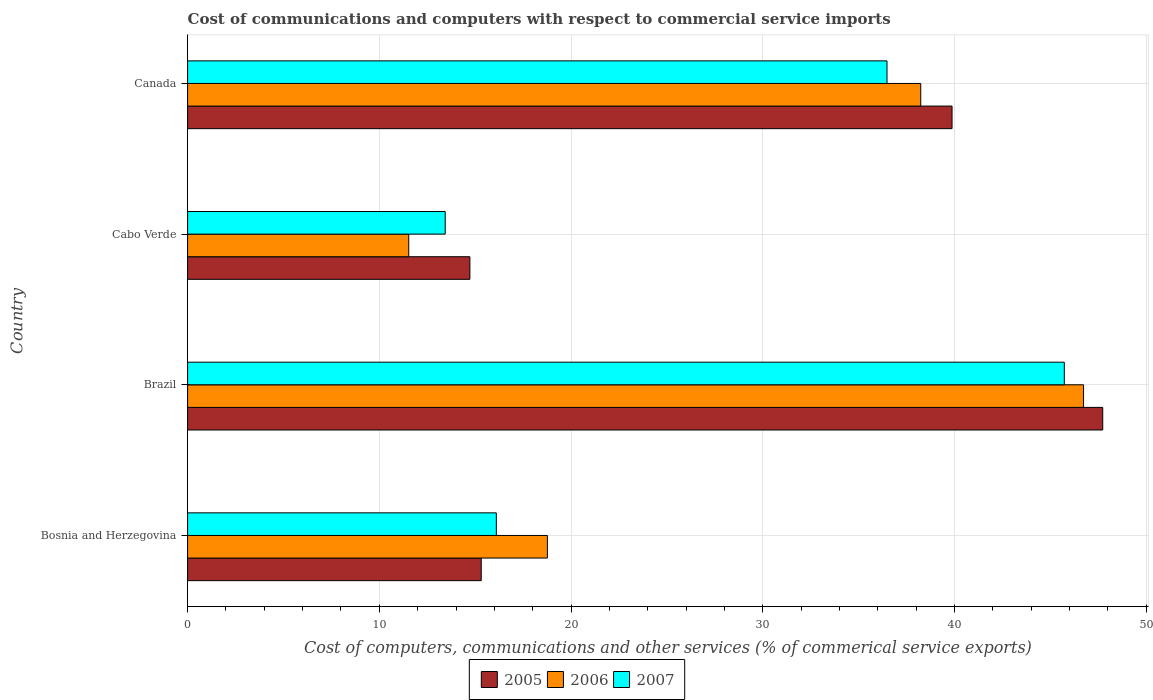How many groups of bars are there?
Your answer should be very brief. 4. Are the number of bars on each tick of the Y-axis equal?
Keep it short and to the point. Yes. How many bars are there on the 4th tick from the top?
Give a very brief answer. 3. What is the label of the 4th group of bars from the top?
Make the answer very short. Bosnia and Herzegovina. In how many cases, is the number of bars for a given country not equal to the number of legend labels?
Your response must be concise. 0. What is the cost of communications and computers in 2005 in Brazil?
Ensure brevity in your answer.  47.73. Across all countries, what is the maximum cost of communications and computers in 2006?
Offer a very short reply. 46.73. Across all countries, what is the minimum cost of communications and computers in 2007?
Your answer should be compact. 13.44. In which country was the cost of communications and computers in 2005 minimum?
Make the answer very short. Cabo Verde. What is the total cost of communications and computers in 2005 in the graph?
Provide a succinct answer. 117.63. What is the difference between the cost of communications and computers in 2007 in Cabo Verde and that in Canada?
Your response must be concise. -23.04. What is the difference between the cost of communications and computers in 2005 in Cabo Verde and the cost of communications and computers in 2007 in Brazil?
Offer a terse response. -31. What is the average cost of communications and computers in 2005 per country?
Give a very brief answer. 29.41. What is the difference between the cost of communications and computers in 2007 and cost of communications and computers in 2006 in Brazil?
Your answer should be compact. -1. What is the ratio of the cost of communications and computers in 2007 in Bosnia and Herzegovina to that in Cabo Verde?
Ensure brevity in your answer.  1.2. Is the cost of communications and computers in 2006 in Brazil less than that in Canada?
Your response must be concise. No. What is the difference between the highest and the second highest cost of communications and computers in 2007?
Provide a short and direct response. 9.25. What is the difference between the highest and the lowest cost of communications and computers in 2006?
Provide a short and direct response. 35.19. In how many countries, is the cost of communications and computers in 2007 greater than the average cost of communications and computers in 2007 taken over all countries?
Offer a terse response. 2. Is it the case that in every country, the sum of the cost of communications and computers in 2005 and cost of communications and computers in 2007 is greater than the cost of communications and computers in 2006?
Provide a short and direct response. Yes. How many countries are there in the graph?
Your answer should be very brief. 4. Does the graph contain grids?
Your answer should be compact. Yes. Where does the legend appear in the graph?
Offer a terse response. Bottom center. What is the title of the graph?
Offer a very short reply. Cost of communications and computers with respect to commercial service imports. Does "1997" appear as one of the legend labels in the graph?
Your response must be concise. No. What is the label or title of the X-axis?
Keep it short and to the point. Cost of computers, communications and other services (% of commerical service exports). What is the label or title of the Y-axis?
Provide a succinct answer. Country. What is the Cost of computers, communications and other services (% of commerical service exports) of 2005 in Bosnia and Herzegovina?
Provide a short and direct response. 15.31. What is the Cost of computers, communications and other services (% of commerical service exports) in 2006 in Bosnia and Herzegovina?
Provide a short and direct response. 18.76. What is the Cost of computers, communications and other services (% of commerical service exports) of 2007 in Bosnia and Herzegovina?
Your answer should be very brief. 16.1. What is the Cost of computers, communications and other services (% of commerical service exports) in 2005 in Brazil?
Provide a succinct answer. 47.73. What is the Cost of computers, communications and other services (% of commerical service exports) of 2006 in Brazil?
Offer a very short reply. 46.73. What is the Cost of computers, communications and other services (% of commerical service exports) of 2007 in Brazil?
Make the answer very short. 45.72. What is the Cost of computers, communications and other services (% of commerical service exports) in 2005 in Cabo Verde?
Offer a very short reply. 14.72. What is the Cost of computers, communications and other services (% of commerical service exports) in 2006 in Cabo Verde?
Your answer should be very brief. 11.53. What is the Cost of computers, communications and other services (% of commerical service exports) of 2007 in Cabo Verde?
Your response must be concise. 13.44. What is the Cost of computers, communications and other services (% of commerical service exports) of 2005 in Canada?
Your answer should be very brief. 39.87. What is the Cost of computers, communications and other services (% of commerical service exports) of 2006 in Canada?
Provide a succinct answer. 38.24. What is the Cost of computers, communications and other services (% of commerical service exports) in 2007 in Canada?
Your response must be concise. 36.48. Across all countries, what is the maximum Cost of computers, communications and other services (% of commerical service exports) in 2005?
Offer a very short reply. 47.73. Across all countries, what is the maximum Cost of computers, communications and other services (% of commerical service exports) in 2006?
Your answer should be very brief. 46.73. Across all countries, what is the maximum Cost of computers, communications and other services (% of commerical service exports) in 2007?
Give a very brief answer. 45.72. Across all countries, what is the minimum Cost of computers, communications and other services (% of commerical service exports) in 2005?
Your answer should be compact. 14.72. Across all countries, what is the minimum Cost of computers, communications and other services (% of commerical service exports) in 2006?
Offer a very short reply. 11.53. Across all countries, what is the minimum Cost of computers, communications and other services (% of commerical service exports) of 2007?
Offer a terse response. 13.44. What is the total Cost of computers, communications and other services (% of commerical service exports) of 2005 in the graph?
Your answer should be compact. 117.63. What is the total Cost of computers, communications and other services (% of commerical service exports) of 2006 in the graph?
Your response must be concise. 115.26. What is the total Cost of computers, communications and other services (% of commerical service exports) in 2007 in the graph?
Ensure brevity in your answer.  111.74. What is the difference between the Cost of computers, communications and other services (% of commerical service exports) in 2005 in Bosnia and Herzegovina and that in Brazil?
Provide a short and direct response. -32.41. What is the difference between the Cost of computers, communications and other services (% of commerical service exports) in 2006 in Bosnia and Herzegovina and that in Brazil?
Make the answer very short. -27.96. What is the difference between the Cost of computers, communications and other services (% of commerical service exports) of 2007 in Bosnia and Herzegovina and that in Brazil?
Keep it short and to the point. -29.62. What is the difference between the Cost of computers, communications and other services (% of commerical service exports) of 2005 in Bosnia and Herzegovina and that in Cabo Verde?
Offer a terse response. 0.59. What is the difference between the Cost of computers, communications and other services (% of commerical service exports) of 2006 in Bosnia and Herzegovina and that in Cabo Verde?
Provide a succinct answer. 7.23. What is the difference between the Cost of computers, communications and other services (% of commerical service exports) in 2007 in Bosnia and Herzegovina and that in Cabo Verde?
Keep it short and to the point. 2.67. What is the difference between the Cost of computers, communications and other services (% of commerical service exports) of 2005 in Bosnia and Herzegovina and that in Canada?
Make the answer very short. -24.55. What is the difference between the Cost of computers, communications and other services (% of commerical service exports) in 2006 in Bosnia and Herzegovina and that in Canada?
Your response must be concise. -19.47. What is the difference between the Cost of computers, communications and other services (% of commerical service exports) in 2007 in Bosnia and Herzegovina and that in Canada?
Your answer should be compact. -20.38. What is the difference between the Cost of computers, communications and other services (% of commerical service exports) in 2005 in Brazil and that in Cabo Verde?
Your answer should be compact. 33.01. What is the difference between the Cost of computers, communications and other services (% of commerical service exports) in 2006 in Brazil and that in Cabo Verde?
Your response must be concise. 35.19. What is the difference between the Cost of computers, communications and other services (% of commerical service exports) in 2007 in Brazil and that in Cabo Verde?
Your answer should be compact. 32.29. What is the difference between the Cost of computers, communications and other services (% of commerical service exports) in 2005 in Brazil and that in Canada?
Ensure brevity in your answer.  7.86. What is the difference between the Cost of computers, communications and other services (% of commerical service exports) of 2006 in Brazil and that in Canada?
Make the answer very short. 8.49. What is the difference between the Cost of computers, communications and other services (% of commerical service exports) in 2007 in Brazil and that in Canada?
Ensure brevity in your answer.  9.25. What is the difference between the Cost of computers, communications and other services (% of commerical service exports) of 2005 in Cabo Verde and that in Canada?
Ensure brevity in your answer.  -25.15. What is the difference between the Cost of computers, communications and other services (% of commerical service exports) of 2006 in Cabo Verde and that in Canada?
Ensure brevity in your answer.  -26.7. What is the difference between the Cost of computers, communications and other services (% of commerical service exports) of 2007 in Cabo Verde and that in Canada?
Offer a terse response. -23.04. What is the difference between the Cost of computers, communications and other services (% of commerical service exports) in 2005 in Bosnia and Herzegovina and the Cost of computers, communications and other services (% of commerical service exports) in 2006 in Brazil?
Offer a terse response. -31.41. What is the difference between the Cost of computers, communications and other services (% of commerical service exports) in 2005 in Bosnia and Herzegovina and the Cost of computers, communications and other services (% of commerical service exports) in 2007 in Brazil?
Your answer should be very brief. -30.41. What is the difference between the Cost of computers, communications and other services (% of commerical service exports) in 2006 in Bosnia and Herzegovina and the Cost of computers, communications and other services (% of commerical service exports) in 2007 in Brazil?
Give a very brief answer. -26.96. What is the difference between the Cost of computers, communications and other services (% of commerical service exports) of 2005 in Bosnia and Herzegovina and the Cost of computers, communications and other services (% of commerical service exports) of 2006 in Cabo Verde?
Your answer should be compact. 3.78. What is the difference between the Cost of computers, communications and other services (% of commerical service exports) in 2005 in Bosnia and Herzegovina and the Cost of computers, communications and other services (% of commerical service exports) in 2007 in Cabo Verde?
Your answer should be compact. 1.88. What is the difference between the Cost of computers, communications and other services (% of commerical service exports) of 2006 in Bosnia and Herzegovina and the Cost of computers, communications and other services (% of commerical service exports) of 2007 in Cabo Verde?
Make the answer very short. 5.33. What is the difference between the Cost of computers, communications and other services (% of commerical service exports) of 2005 in Bosnia and Herzegovina and the Cost of computers, communications and other services (% of commerical service exports) of 2006 in Canada?
Give a very brief answer. -22.92. What is the difference between the Cost of computers, communications and other services (% of commerical service exports) of 2005 in Bosnia and Herzegovina and the Cost of computers, communications and other services (% of commerical service exports) of 2007 in Canada?
Your answer should be compact. -21.16. What is the difference between the Cost of computers, communications and other services (% of commerical service exports) in 2006 in Bosnia and Herzegovina and the Cost of computers, communications and other services (% of commerical service exports) in 2007 in Canada?
Make the answer very short. -17.71. What is the difference between the Cost of computers, communications and other services (% of commerical service exports) of 2005 in Brazil and the Cost of computers, communications and other services (% of commerical service exports) of 2006 in Cabo Verde?
Your answer should be very brief. 36.2. What is the difference between the Cost of computers, communications and other services (% of commerical service exports) in 2005 in Brazil and the Cost of computers, communications and other services (% of commerical service exports) in 2007 in Cabo Verde?
Keep it short and to the point. 34.29. What is the difference between the Cost of computers, communications and other services (% of commerical service exports) in 2006 in Brazil and the Cost of computers, communications and other services (% of commerical service exports) in 2007 in Cabo Verde?
Keep it short and to the point. 33.29. What is the difference between the Cost of computers, communications and other services (% of commerical service exports) in 2005 in Brazil and the Cost of computers, communications and other services (% of commerical service exports) in 2006 in Canada?
Give a very brief answer. 9.49. What is the difference between the Cost of computers, communications and other services (% of commerical service exports) in 2005 in Brazil and the Cost of computers, communications and other services (% of commerical service exports) in 2007 in Canada?
Ensure brevity in your answer.  11.25. What is the difference between the Cost of computers, communications and other services (% of commerical service exports) of 2006 in Brazil and the Cost of computers, communications and other services (% of commerical service exports) of 2007 in Canada?
Offer a terse response. 10.25. What is the difference between the Cost of computers, communications and other services (% of commerical service exports) of 2005 in Cabo Verde and the Cost of computers, communications and other services (% of commerical service exports) of 2006 in Canada?
Offer a very short reply. -23.51. What is the difference between the Cost of computers, communications and other services (% of commerical service exports) in 2005 in Cabo Verde and the Cost of computers, communications and other services (% of commerical service exports) in 2007 in Canada?
Keep it short and to the point. -21.75. What is the difference between the Cost of computers, communications and other services (% of commerical service exports) in 2006 in Cabo Verde and the Cost of computers, communications and other services (% of commerical service exports) in 2007 in Canada?
Offer a very short reply. -24.94. What is the average Cost of computers, communications and other services (% of commerical service exports) in 2005 per country?
Ensure brevity in your answer.  29.41. What is the average Cost of computers, communications and other services (% of commerical service exports) in 2006 per country?
Provide a short and direct response. 28.82. What is the average Cost of computers, communications and other services (% of commerical service exports) in 2007 per country?
Offer a terse response. 27.93. What is the difference between the Cost of computers, communications and other services (% of commerical service exports) of 2005 and Cost of computers, communications and other services (% of commerical service exports) of 2006 in Bosnia and Herzegovina?
Keep it short and to the point. -3.45. What is the difference between the Cost of computers, communications and other services (% of commerical service exports) of 2005 and Cost of computers, communications and other services (% of commerical service exports) of 2007 in Bosnia and Herzegovina?
Your answer should be very brief. -0.79. What is the difference between the Cost of computers, communications and other services (% of commerical service exports) of 2006 and Cost of computers, communications and other services (% of commerical service exports) of 2007 in Bosnia and Herzegovina?
Make the answer very short. 2.66. What is the difference between the Cost of computers, communications and other services (% of commerical service exports) of 2005 and Cost of computers, communications and other services (% of commerical service exports) of 2007 in Brazil?
Give a very brief answer. 2. What is the difference between the Cost of computers, communications and other services (% of commerical service exports) of 2005 and Cost of computers, communications and other services (% of commerical service exports) of 2006 in Cabo Verde?
Give a very brief answer. 3.19. What is the difference between the Cost of computers, communications and other services (% of commerical service exports) of 2005 and Cost of computers, communications and other services (% of commerical service exports) of 2007 in Cabo Verde?
Give a very brief answer. 1.29. What is the difference between the Cost of computers, communications and other services (% of commerical service exports) of 2006 and Cost of computers, communications and other services (% of commerical service exports) of 2007 in Cabo Verde?
Offer a very short reply. -1.9. What is the difference between the Cost of computers, communications and other services (% of commerical service exports) in 2005 and Cost of computers, communications and other services (% of commerical service exports) in 2006 in Canada?
Your answer should be very brief. 1.63. What is the difference between the Cost of computers, communications and other services (% of commerical service exports) in 2005 and Cost of computers, communications and other services (% of commerical service exports) in 2007 in Canada?
Offer a very short reply. 3.39. What is the difference between the Cost of computers, communications and other services (% of commerical service exports) of 2006 and Cost of computers, communications and other services (% of commerical service exports) of 2007 in Canada?
Provide a succinct answer. 1.76. What is the ratio of the Cost of computers, communications and other services (% of commerical service exports) of 2005 in Bosnia and Herzegovina to that in Brazil?
Your answer should be very brief. 0.32. What is the ratio of the Cost of computers, communications and other services (% of commerical service exports) of 2006 in Bosnia and Herzegovina to that in Brazil?
Make the answer very short. 0.4. What is the ratio of the Cost of computers, communications and other services (% of commerical service exports) in 2007 in Bosnia and Herzegovina to that in Brazil?
Your answer should be compact. 0.35. What is the ratio of the Cost of computers, communications and other services (% of commerical service exports) in 2005 in Bosnia and Herzegovina to that in Cabo Verde?
Your answer should be very brief. 1.04. What is the ratio of the Cost of computers, communications and other services (% of commerical service exports) in 2006 in Bosnia and Herzegovina to that in Cabo Verde?
Your answer should be very brief. 1.63. What is the ratio of the Cost of computers, communications and other services (% of commerical service exports) of 2007 in Bosnia and Herzegovina to that in Cabo Verde?
Keep it short and to the point. 1.2. What is the ratio of the Cost of computers, communications and other services (% of commerical service exports) in 2005 in Bosnia and Herzegovina to that in Canada?
Your answer should be compact. 0.38. What is the ratio of the Cost of computers, communications and other services (% of commerical service exports) of 2006 in Bosnia and Herzegovina to that in Canada?
Ensure brevity in your answer.  0.49. What is the ratio of the Cost of computers, communications and other services (% of commerical service exports) of 2007 in Bosnia and Herzegovina to that in Canada?
Provide a succinct answer. 0.44. What is the ratio of the Cost of computers, communications and other services (% of commerical service exports) in 2005 in Brazil to that in Cabo Verde?
Keep it short and to the point. 3.24. What is the ratio of the Cost of computers, communications and other services (% of commerical service exports) of 2006 in Brazil to that in Cabo Verde?
Provide a succinct answer. 4.05. What is the ratio of the Cost of computers, communications and other services (% of commerical service exports) in 2007 in Brazil to that in Cabo Verde?
Offer a terse response. 3.4. What is the ratio of the Cost of computers, communications and other services (% of commerical service exports) of 2005 in Brazil to that in Canada?
Provide a succinct answer. 1.2. What is the ratio of the Cost of computers, communications and other services (% of commerical service exports) in 2006 in Brazil to that in Canada?
Keep it short and to the point. 1.22. What is the ratio of the Cost of computers, communications and other services (% of commerical service exports) of 2007 in Brazil to that in Canada?
Keep it short and to the point. 1.25. What is the ratio of the Cost of computers, communications and other services (% of commerical service exports) of 2005 in Cabo Verde to that in Canada?
Offer a terse response. 0.37. What is the ratio of the Cost of computers, communications and other services (% of commerical service exports) of 2006 in Cabo Verde to that in Canada?
Your answer should be compact. 0.3. What is the ratio of the Cost of computers, communications and other services (% of commerical service exports) in 2007 in Cabo Verde to that in Canada?
Offer a very short reply. 0.37. What is the difference between the highest and the second highest Cost of computers, communications and other services (% of commerical service exports) of 2005?
Provide a succinct answer. 7.86. What is the difference between the highest and the second highest Cost of computers, communications and other services (% of commerical service exports) of 2006?
Keep it short and to the point. 8.49. What is the difference between the highest and the second highest Cost of computers, communications and other services (% of commerical service exports) in 2007?
Offer a very short reply. 9.25. What is the difference between the highest and the lowest Cost of computers, communications and other services (% of commerical service exports) of 2005?
Make the answer very short. 33.01. What is the difference between the highest and the lowest Cost of computers, communications and other services (% of commerical service exports) in 2006?
Provide a succinct answer. 35.19. What is the difference between the highest and the lowest Cost of computers, communications and other services (% of commerical service exports) of 2007?
Give a very brief answer. 32.29. 